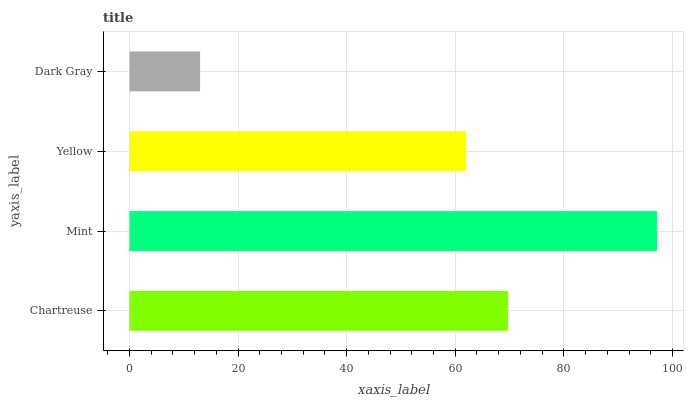Is Dark Gray the minimum?
Answer yes or no. Yes. Is Mint the maximum?
Answer yes or no. Yes. Is Yellow the minimum?
Answer yes or no. No. Is Yellow the maximum?
Answer yes or no. No. Is Mint greater than Yellow?
Answer yes or no. Yes. Is Yellow less than Mint?
Answer yes or no. Yes. Is Yellow greater than Mint?
Answer yes or no. No. Is Mint less than Yellow?
Answer yes or no. No. Is Chartreuse the high median?
Answer yes or no. Yes. Is Yellow the low median?
Answer yes or no. Yes. Is Yellow the high median?
Answer yes or no. No. Is Chartreuse the low median?
Answer yes or no. No. 